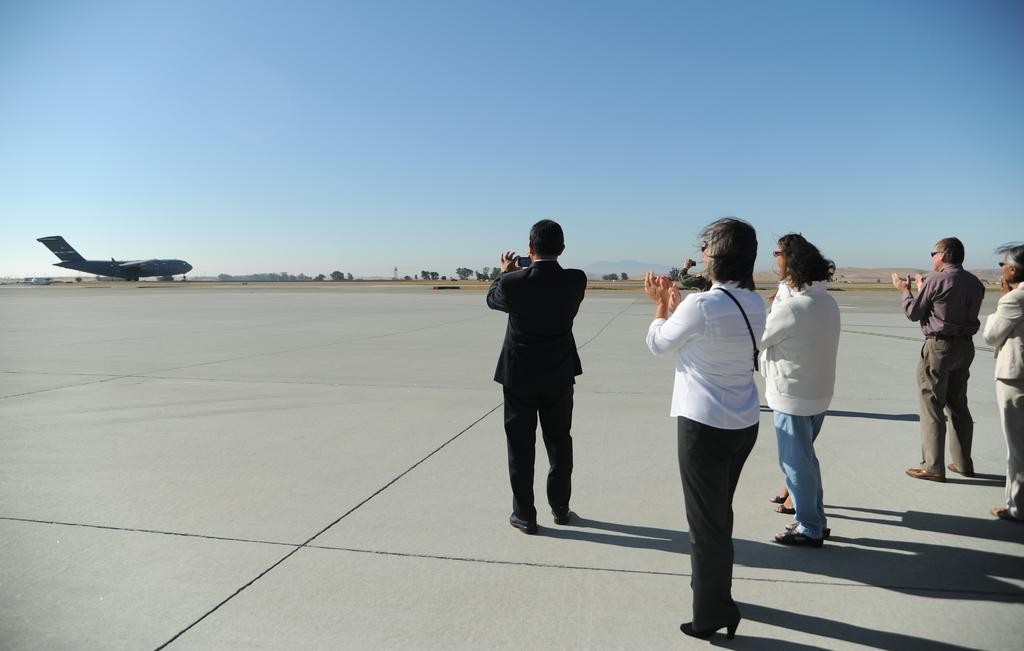What can be seen in the right corner of the image? There are people standing in the right corner of the image. What are the people doing in the image? One of the people is holding a camera. What is located in front of the people in the image? There is a plane in front of the people. What type of natural scenery is visible in the background of the image? There are trees in the background of the image. What type of net is being used by the people in the image? There is no net present in the image; the people are holding a camera and standing near a plane. What statement is being made by the people in the image? There is no specific statement being made by the people in the image; they are simply holding a camera and standing near a plane. 